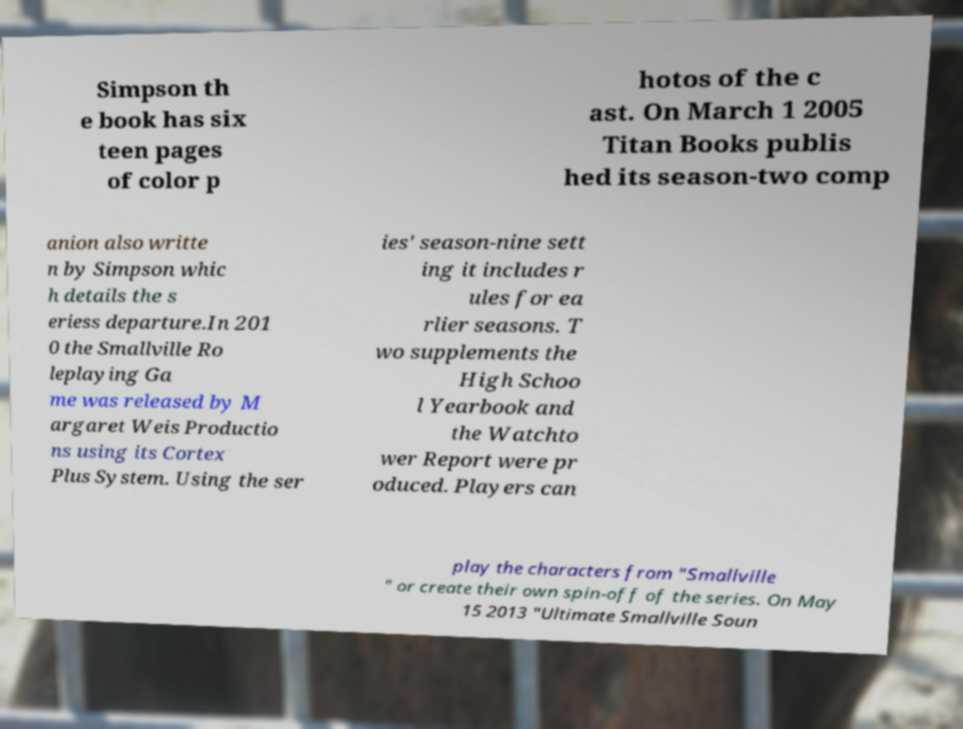I need the written content from this picture converted into text. Can you do that? Simpson th e book has six teen pages of color p hotos of the c ast. On March 1 2005 Titan Books publis hed its season-two comp anion also writte n by Simpson whic h details the s eriess departure.In 201 0 the Smallville Ro leplaying Ga me was released by M argaret Weis Productio ns using its Cortex Plus System. Using the ser ies' season-nine sett ing it includes r ules for ea rlier seasons. T wo supplements the High Schoo l Yearbook and the Watchto wer Report were pr oduced. Players can play the characters from "Smallville " or create their own spin-off of the series. On May 15 2013 "Ultimate Smallville Soun 